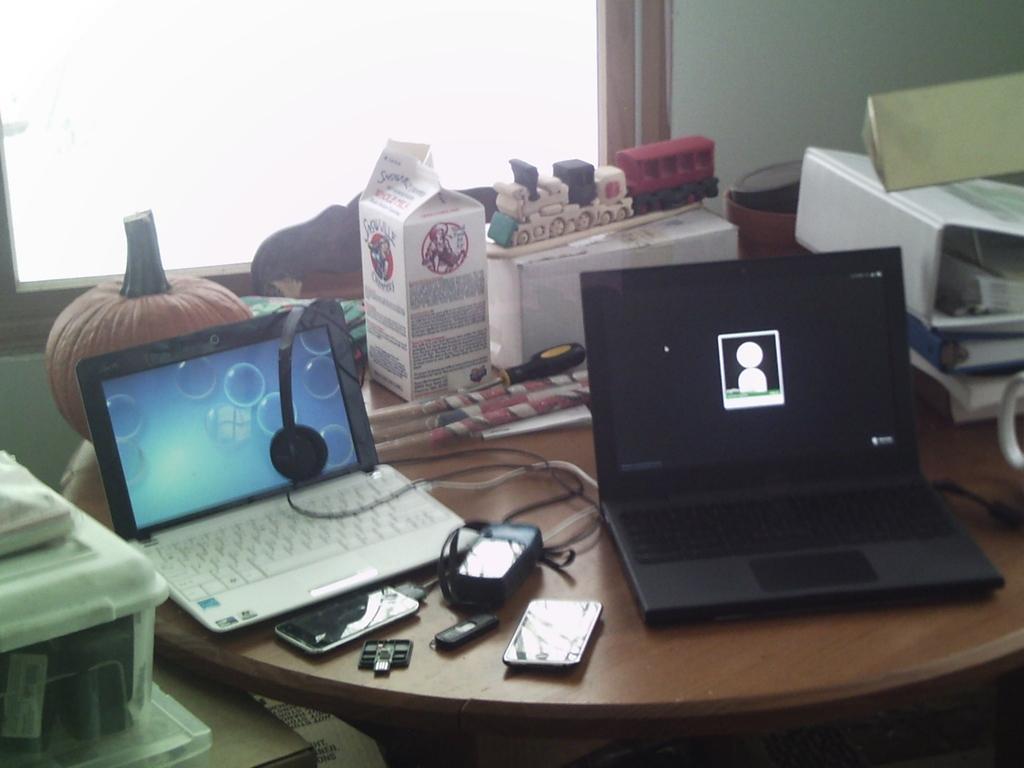Could you give a brief overview of what you see in this image? Here we can see a couple of laptops on a table and there are mobile phones present on the table and there are some other things present on the table 